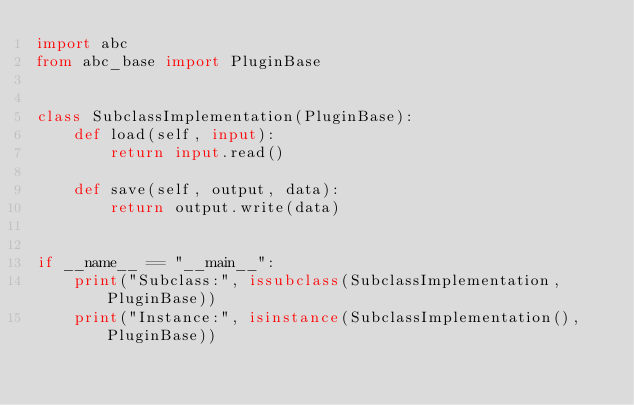Convert code to text. <code><loc_0><loc_0><loc_500><loc_500><_Python_>import abc
from abc_base import PluginBase


class SubclassImplementation(PluginBase):
    def load(self, input):
        return input.read()

    def save(self, output, data):
        return output.write(data)


if __name__ == "__main__":
    print("Subclass:", issubclass(SubclassImplementation, PluginBase))
    print("Instance:", isinstance(SubclassImplementation(), PluginBase))
</code> 